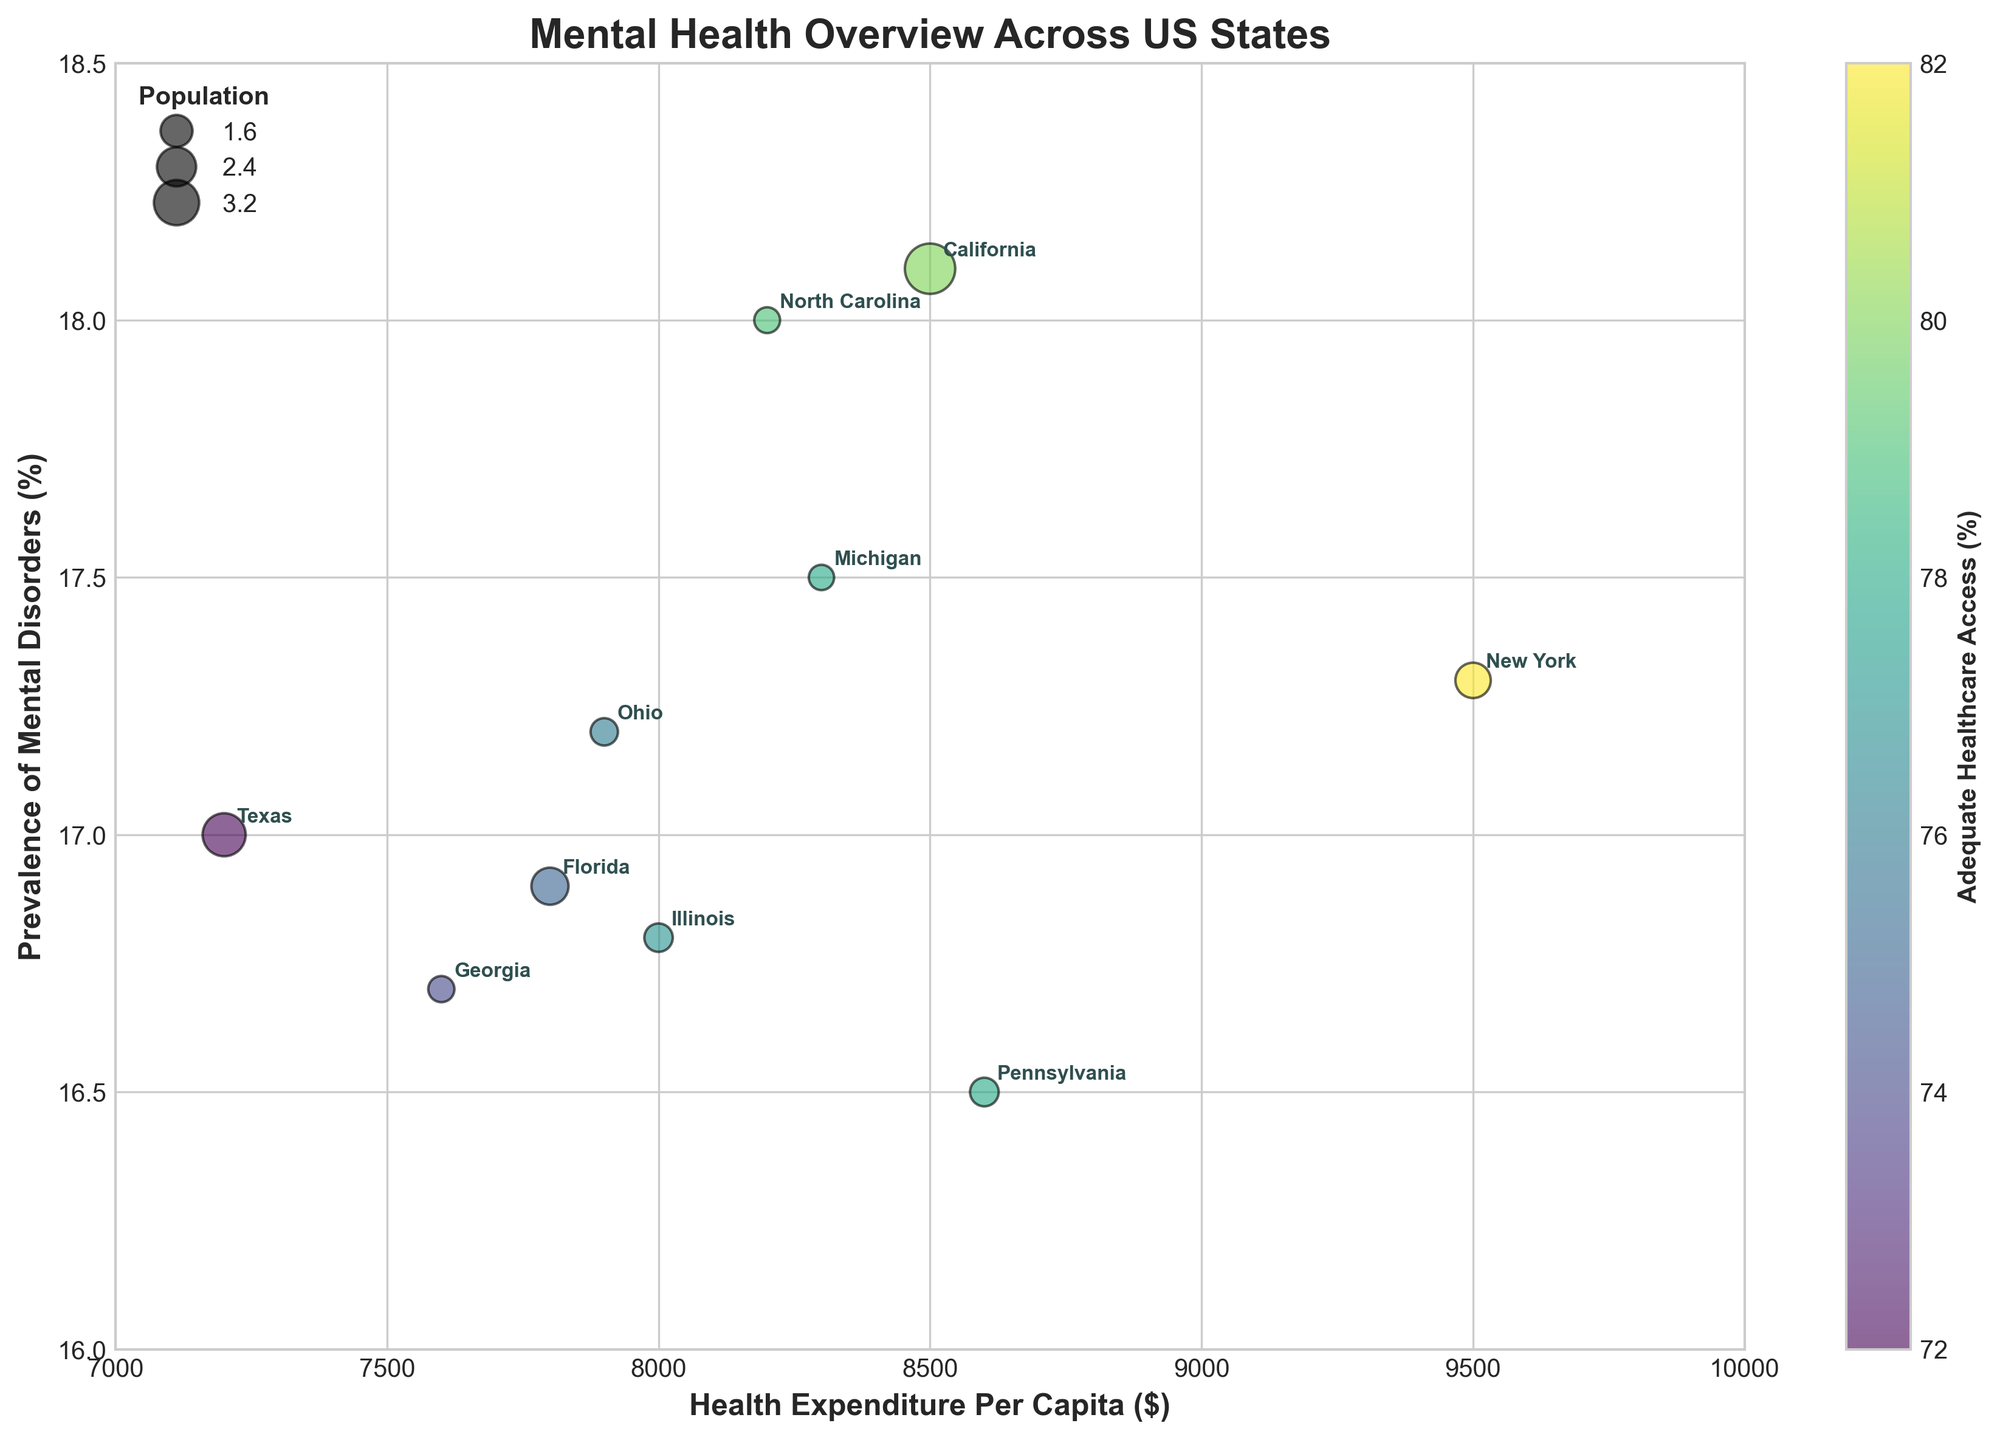What does the title of the figure indicate? The figure's title is "Mental Health Overview Across US States." This indicates the visualization provides a general view of mental health statistics across different states in the United States.
Answer: Mental Health Overview Across US States What does the x-axis represent in this chart? The x-axis represents the "Health Expenditure Per Capita" in dollars. This shows how much each state spends on health care per person.
Answer: Health Expenditure Per Capita ($) What is the meaning of the bubble size in the chart? The size of each bubble represents the population of the corresponding state. Larger bubbles indicate states with higher populations.
Answer: Population What color represents the Adequate Healthcare Access parameter, and how is it encoded? The Adequate Healthcare Access parameter is represented by a color gradient. The color varies from dark to light, with a color bar on the right to indicate the percentage. States with higher percentages of adequate healthcare access are lighter in color.
Answer: Color gradient Which state has the highest prevalence of mental disorders and the lowest health expenditure per capita? Texas has the highest prevalence of mental disorders at 17.0% and the lowest health expenditure per capita at $7,200 among the listed states.
Answer: Texas How does the prevalence of mental disorders in New York compare to that in Illinois? The prevalence of mental disorders in New York is 17.3%, which is slightly higher than in Illinois at 16.8%.
Answer: New York is higher than Illinois If a state has high healthcare expenditure, does it correlate with a high prevalence of mental disorders in this chart? States with high healthcare expenditure do not consistently show high prevalence of mental disorders. For example, New York has high expenditure ($9,500) and a relatively high prevalence (17.3%), while Pennsylvania has high expenditure ($8600) but lower prevalence (16.5%).
Answer: No consistent correlation What state has both high prevalence of mental disorders and high adequate healthcare access? New York has both a high prevalence of mental disorders at 17.3% and high adequate healthcare access at 82%.
Answer: New York Based on bubble sizes, which states have significantly larger or smaller populations? California and Texas have significantly larger populations as indicated by their larger bubble sizes. States like Michigan and Pennsylvania have smaller bubble sizes and therefore smaller populations.
Answer: California and Texas are larger; Michigan and Pennsylvania are smaller 